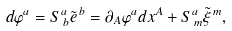<formula> <loc_0><loc_0><loc_500><loc_500>d \varphi ^ { a } = S ^ { a } _ { \, b } \tilde { e } ^ { \, b } = \partial _ { A } \varphi ^ { a } d x ^ { A } + S ^ { a } _ { \, m } \tilde { \xi } ^ { \, m } ,</formula> 